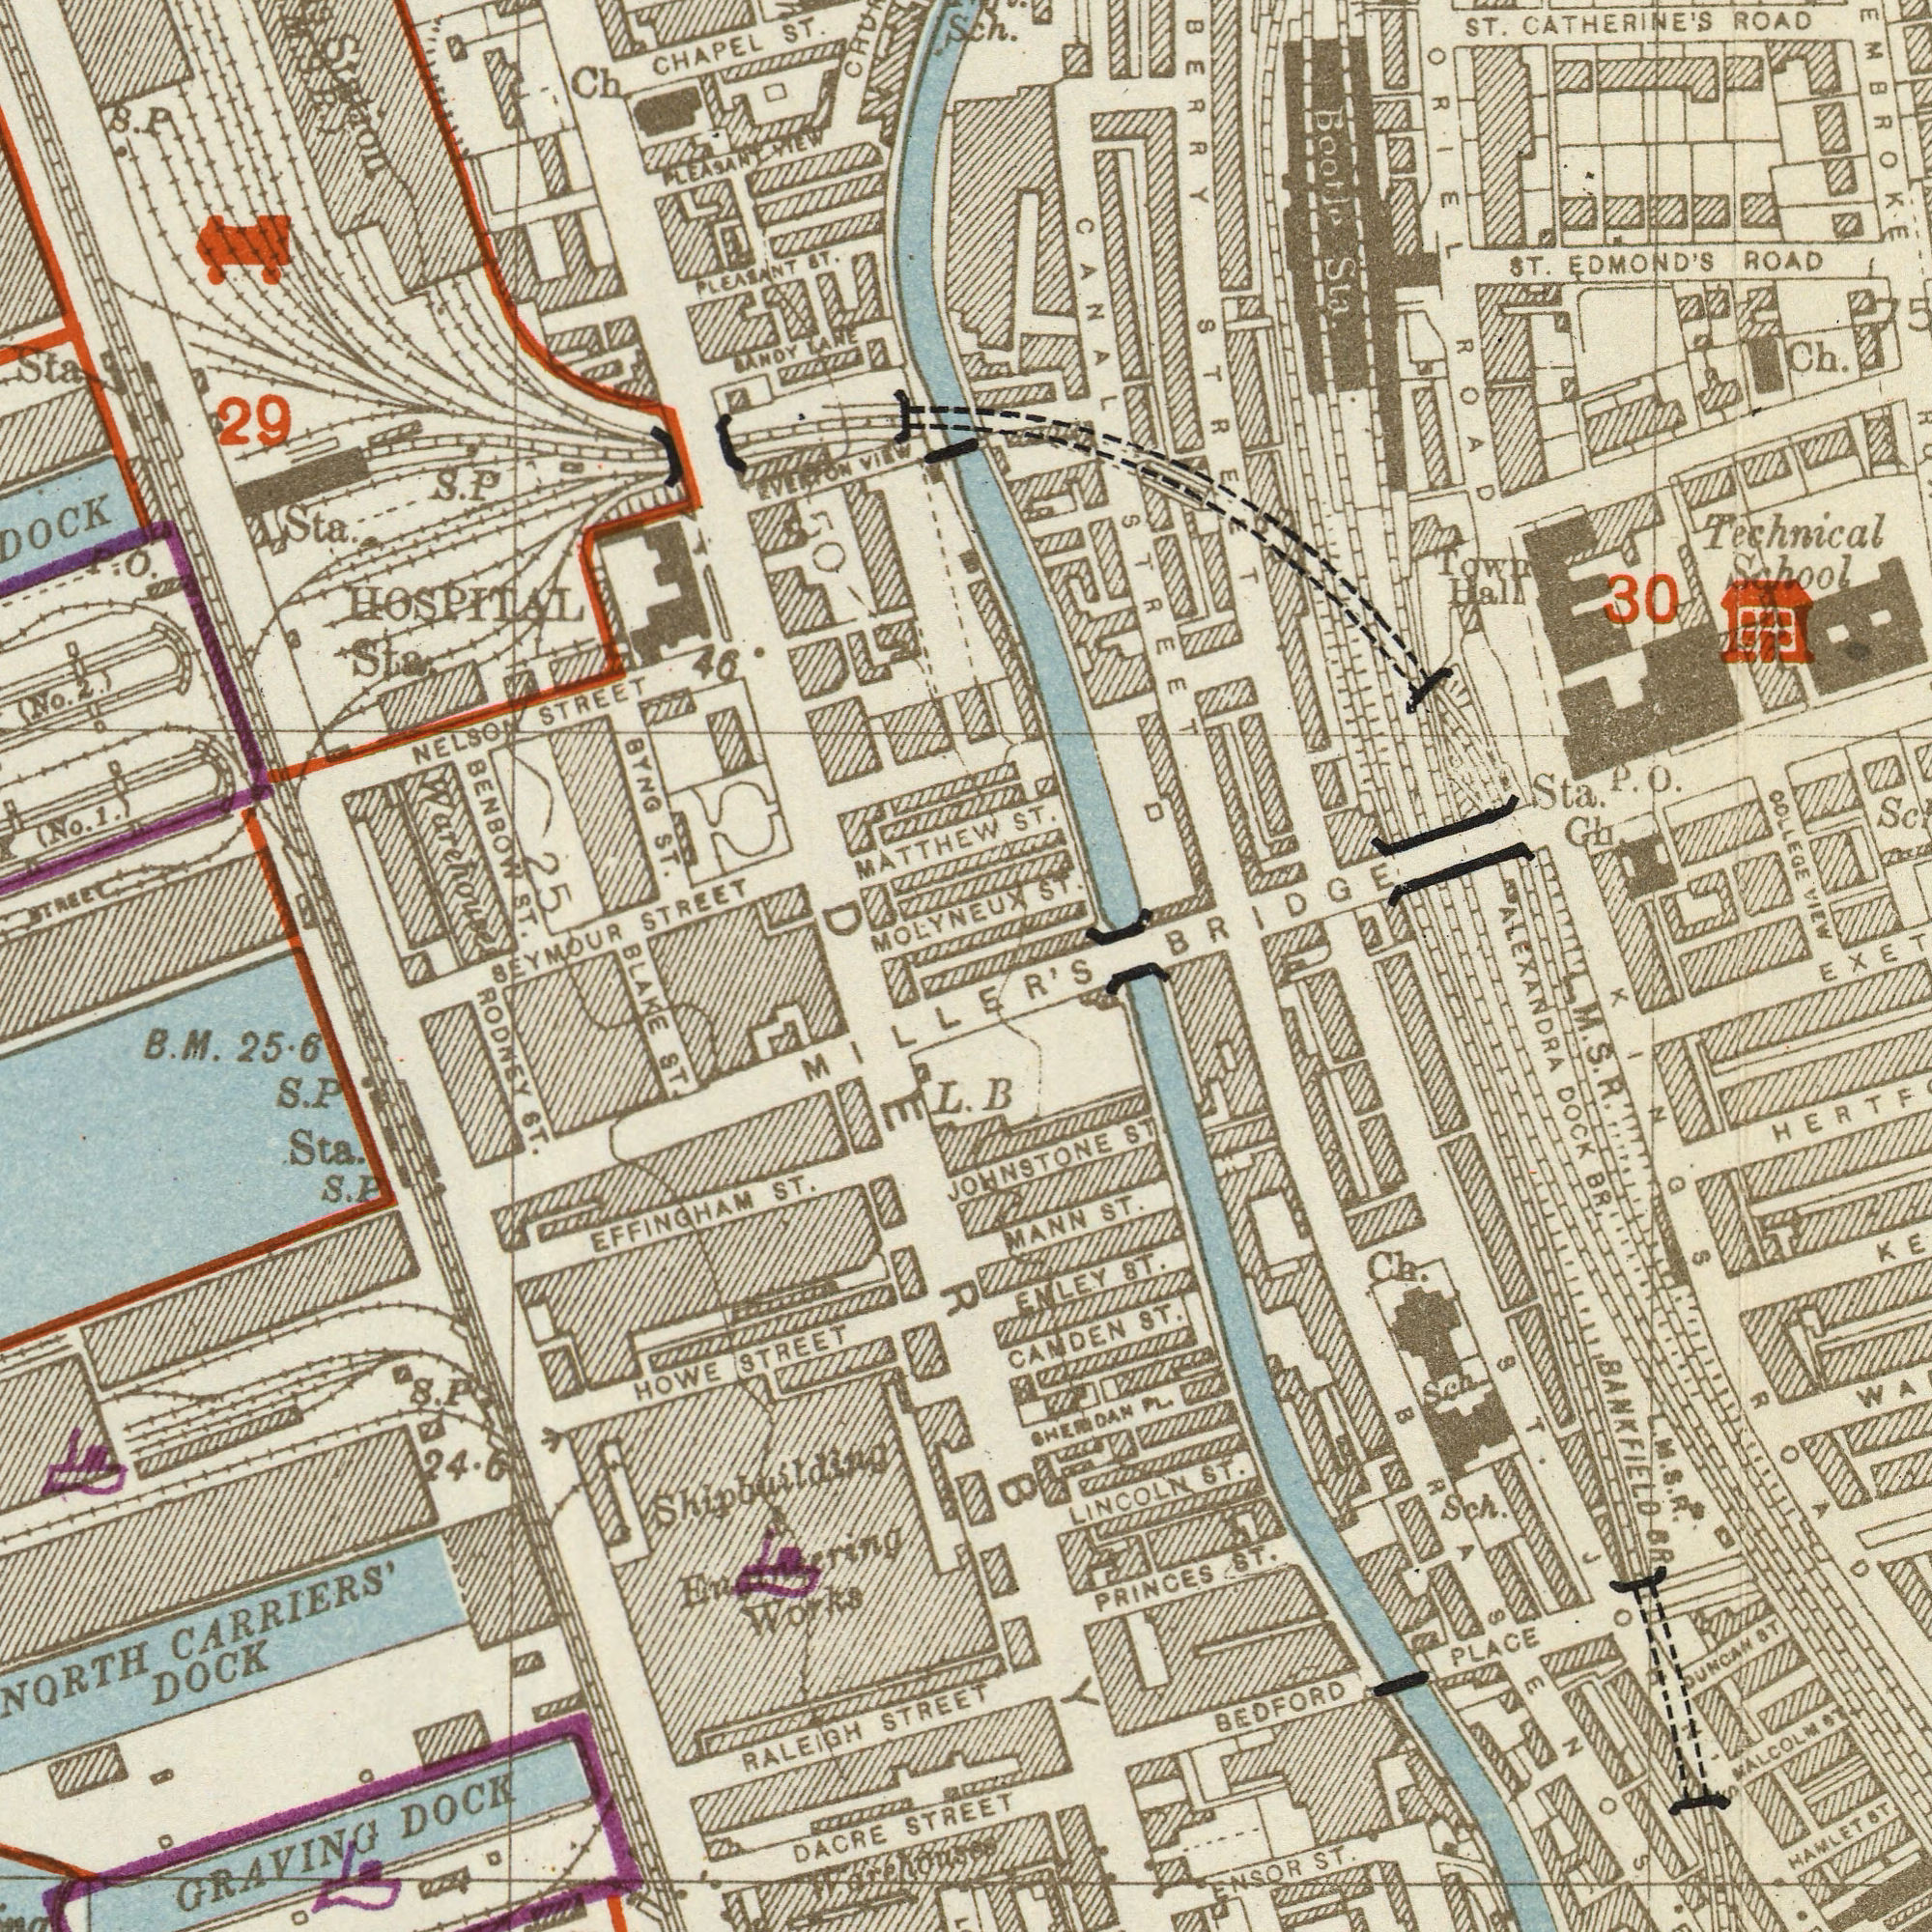What text is shown in the top-left quadrant? CHAPEL STREET STREET BYNG MOLYNEUX Sta. S. BENBOW NELSON Ch ST. MATTHEW (No. (No. PLEASANT 29 1.) S. Sta ST. PLEASANT Sta. ST. 46 STREET HOSPITAL P. 2.) ST. SEYMOUR LANE NEW Warehouses LANDY Station M. S. P.) P O. P VIEW EVERION 50 25 What text appears in the bottom-left area of the image? CARRIERS' GRAVING EFFINGHAM DOCK ST. HOWE Sta. Works ST. ST. DACRE 25.6 STREET S. S. BLAKE RALEIGH STREET RODNEY STREET MILLER'S 24.6 S. Warehouses B. Shipbuilding DOCK DERBY L. M. P P P & What text is visible in the lower-right corner? BANKFIELD PRINCES BEDFORD CAMDEN LINCOLN MANN ST. ST. ST. ST. ST. ENLEY ALEXANDRA ENSOR ST. DOCK BR. Ch. PLACE B DUNCAN JOHNSTONE HAWLET ST. ST ###R Sch. SHERIDAN ST WALCOLM Sch. M. L. M. S. R. ROAD KINGS ST. PL. JOHN'S S. R. ST L. What text appears in the top-right area of the image? CATHERINE'S COLLEGE EDMOND'S ST. Ch. Sta. ROAD ST. 30 Technical Ch School ST. Bootle Sch. ROAD VIEW BERRY Town BRIDGE Hall Sta. STREET ORIEL ST. P. STREET ROAD CANAL 75 O. 